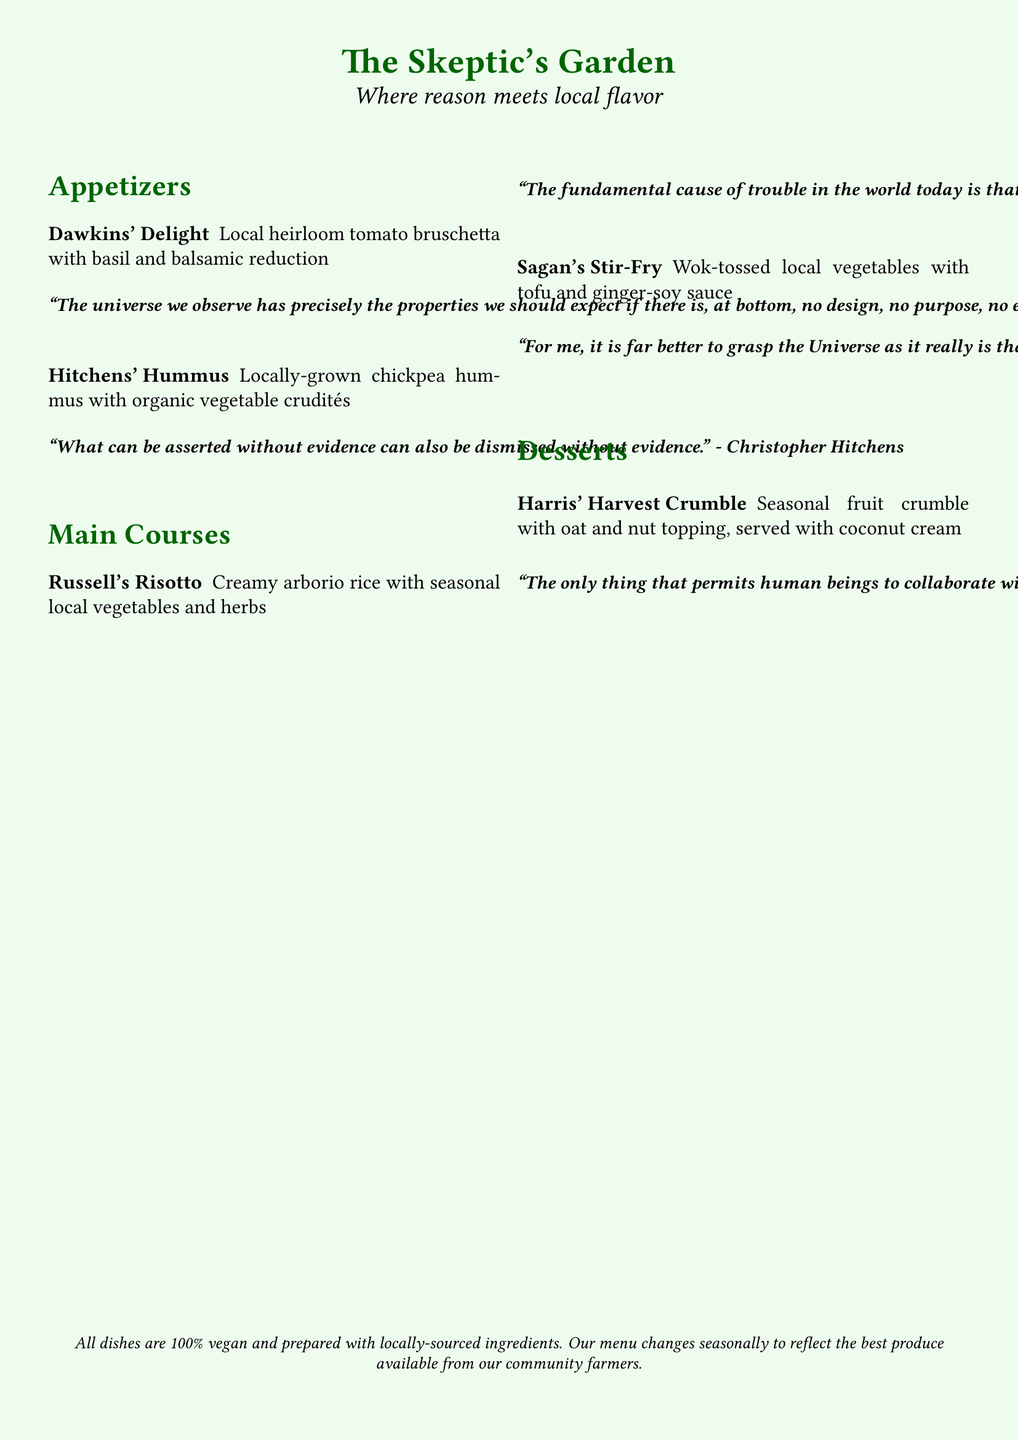What is the name of the appetizer featuring heirloom tomatoes? The name listed in the menu for the appetizer with heirloom tomatoes is "Dawkins' Delight."
Answer: Dawkins' Delight Who authored the quote associated with "Hitchens' Hummus"? The quote associated with "Hitchens' Hummus" is attributed to Christopher Hitchens.
Answer: Christopher Hitchens What is the main ingredient in "Russell's Risotto"? The main ingredient of "Russell's Risotto" includes creamy arborio rice along with seasonal local vegetables and herbs.
Answer: Arborio rice How many seasons does the menu change to reflect local produce? The menu changes seasonally, indicating it reflects local produce available at different times of the year.
Answer: Seasonally What dessert features an oat and nut topping? The dessert with an oat and nut topping is "Harris' Harvest Crumble."
Answer: Harris' Harvest Crumble What type of sauce is used in "Sagan's Stir-Fry"? The sauce mentioned for "Sagan's Stir-Fry" is ginger-soy sauce.
Answer: Ginger-soy sauce Are all dishes on the menu vegan? The document explicitly states that all dishes are 100% vegan.
Answer: Yes What is the color theme of the menu's background? The background of the menu is in a light green shade.
Answer: Light green 